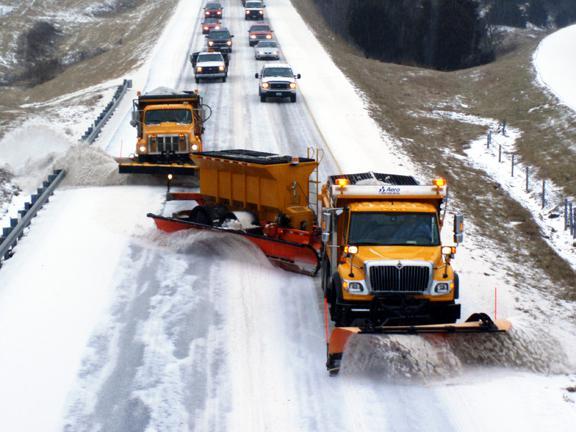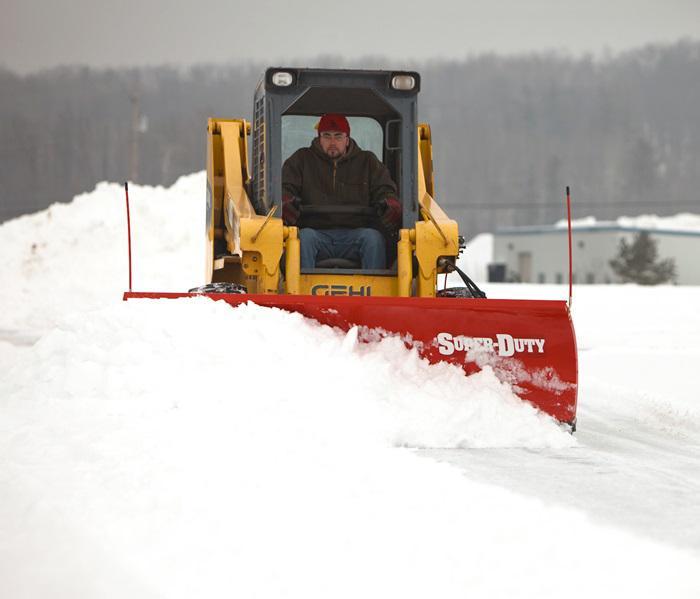The first image is the image on the left, the second image is the image on the right. Assess this claim about the two images: "A truck with yellow bulldozer panel is pushing a pile of snow.". Correct or not? Answer yes or no. No. 